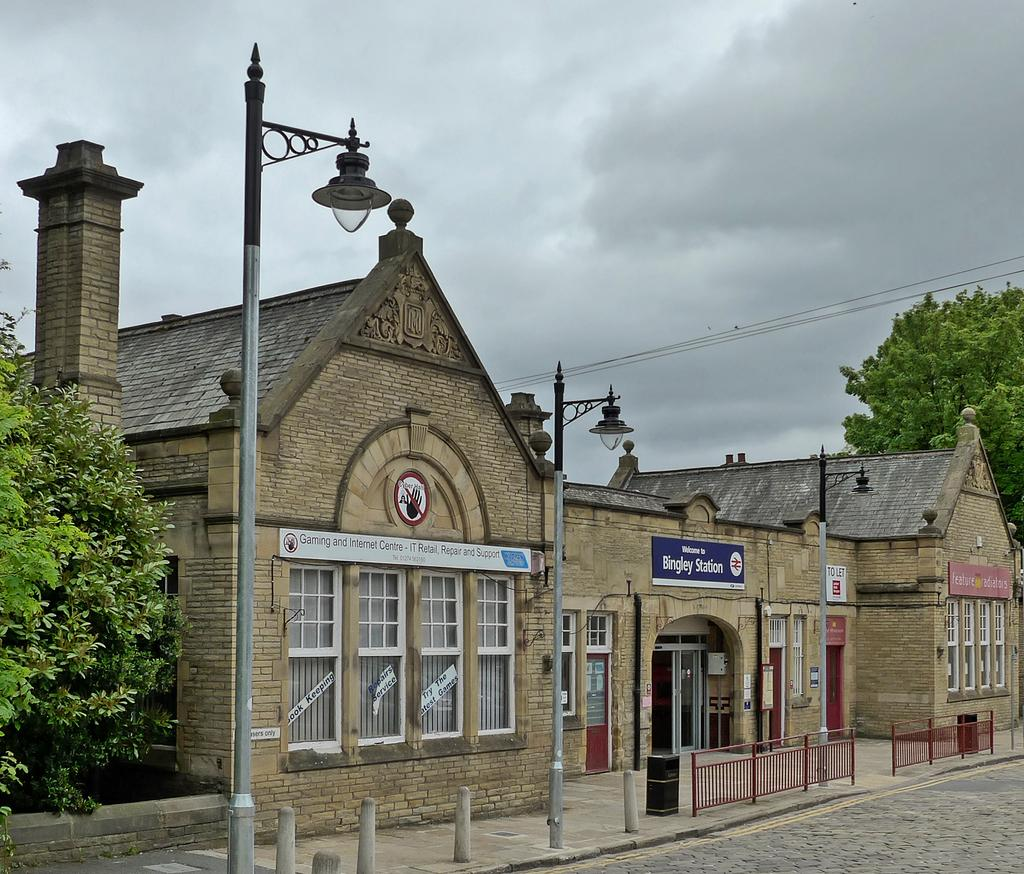What type of structures can be seen in the image? There are buildings with windows in the image. What is present near the buildings? There is a fence in the image. What other objects can be seen in the image? There are poles, trees, wires, and name boards in the image. What is the ground surface like in the image? There is a road in the image. What can be seen in the background of the image? The sky with clouds is visible in the background of the image. What type of apparel is being worn by the trees in the image? Trees do not wear apparel; they are plants and do not have clothing. Can you describe the mist in the image? There is no mention of mist in the image; it only describes the sky with clouds in the background. 